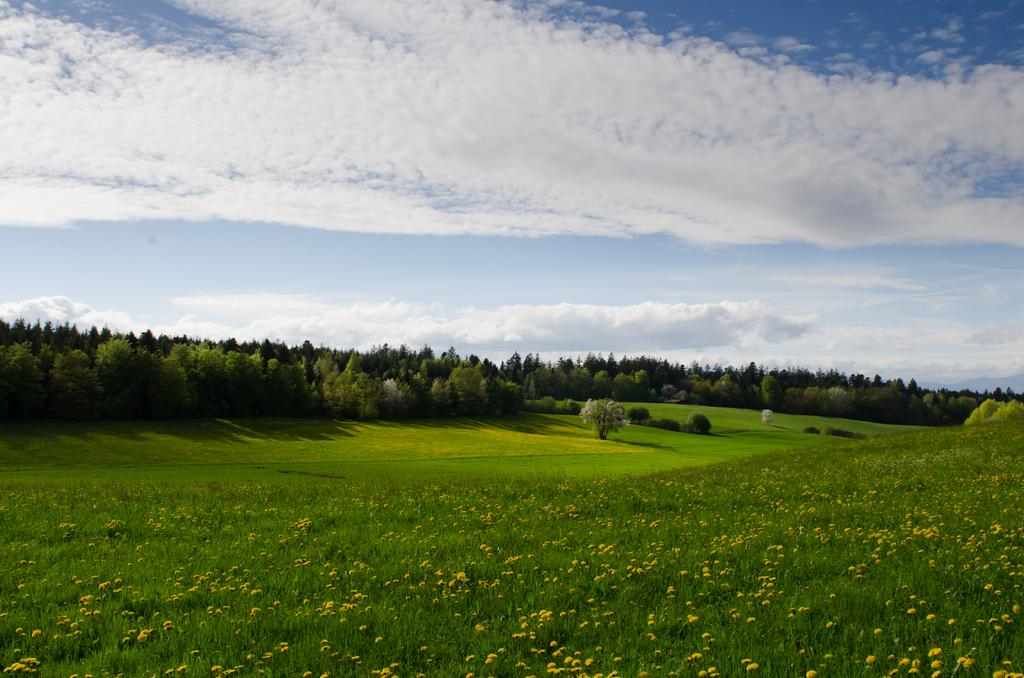What type of plants can be seen on the ground in the image? There are flower plants on the ground in the image. What type of vegetation is visible besides the flower plants? There is grass visible in the image. What can be seen in the background of the image? There are trees and the sky visible in the background of the image. What is the condition of the sky in the image? The sky has clouds in it. Can you see any quicksand in the image? There is no quicksand present in the image. Is anyone wearing a scarf in the image? There are no people visible in the image, so it is impossible to determine if anyone is wearing a scarf. 